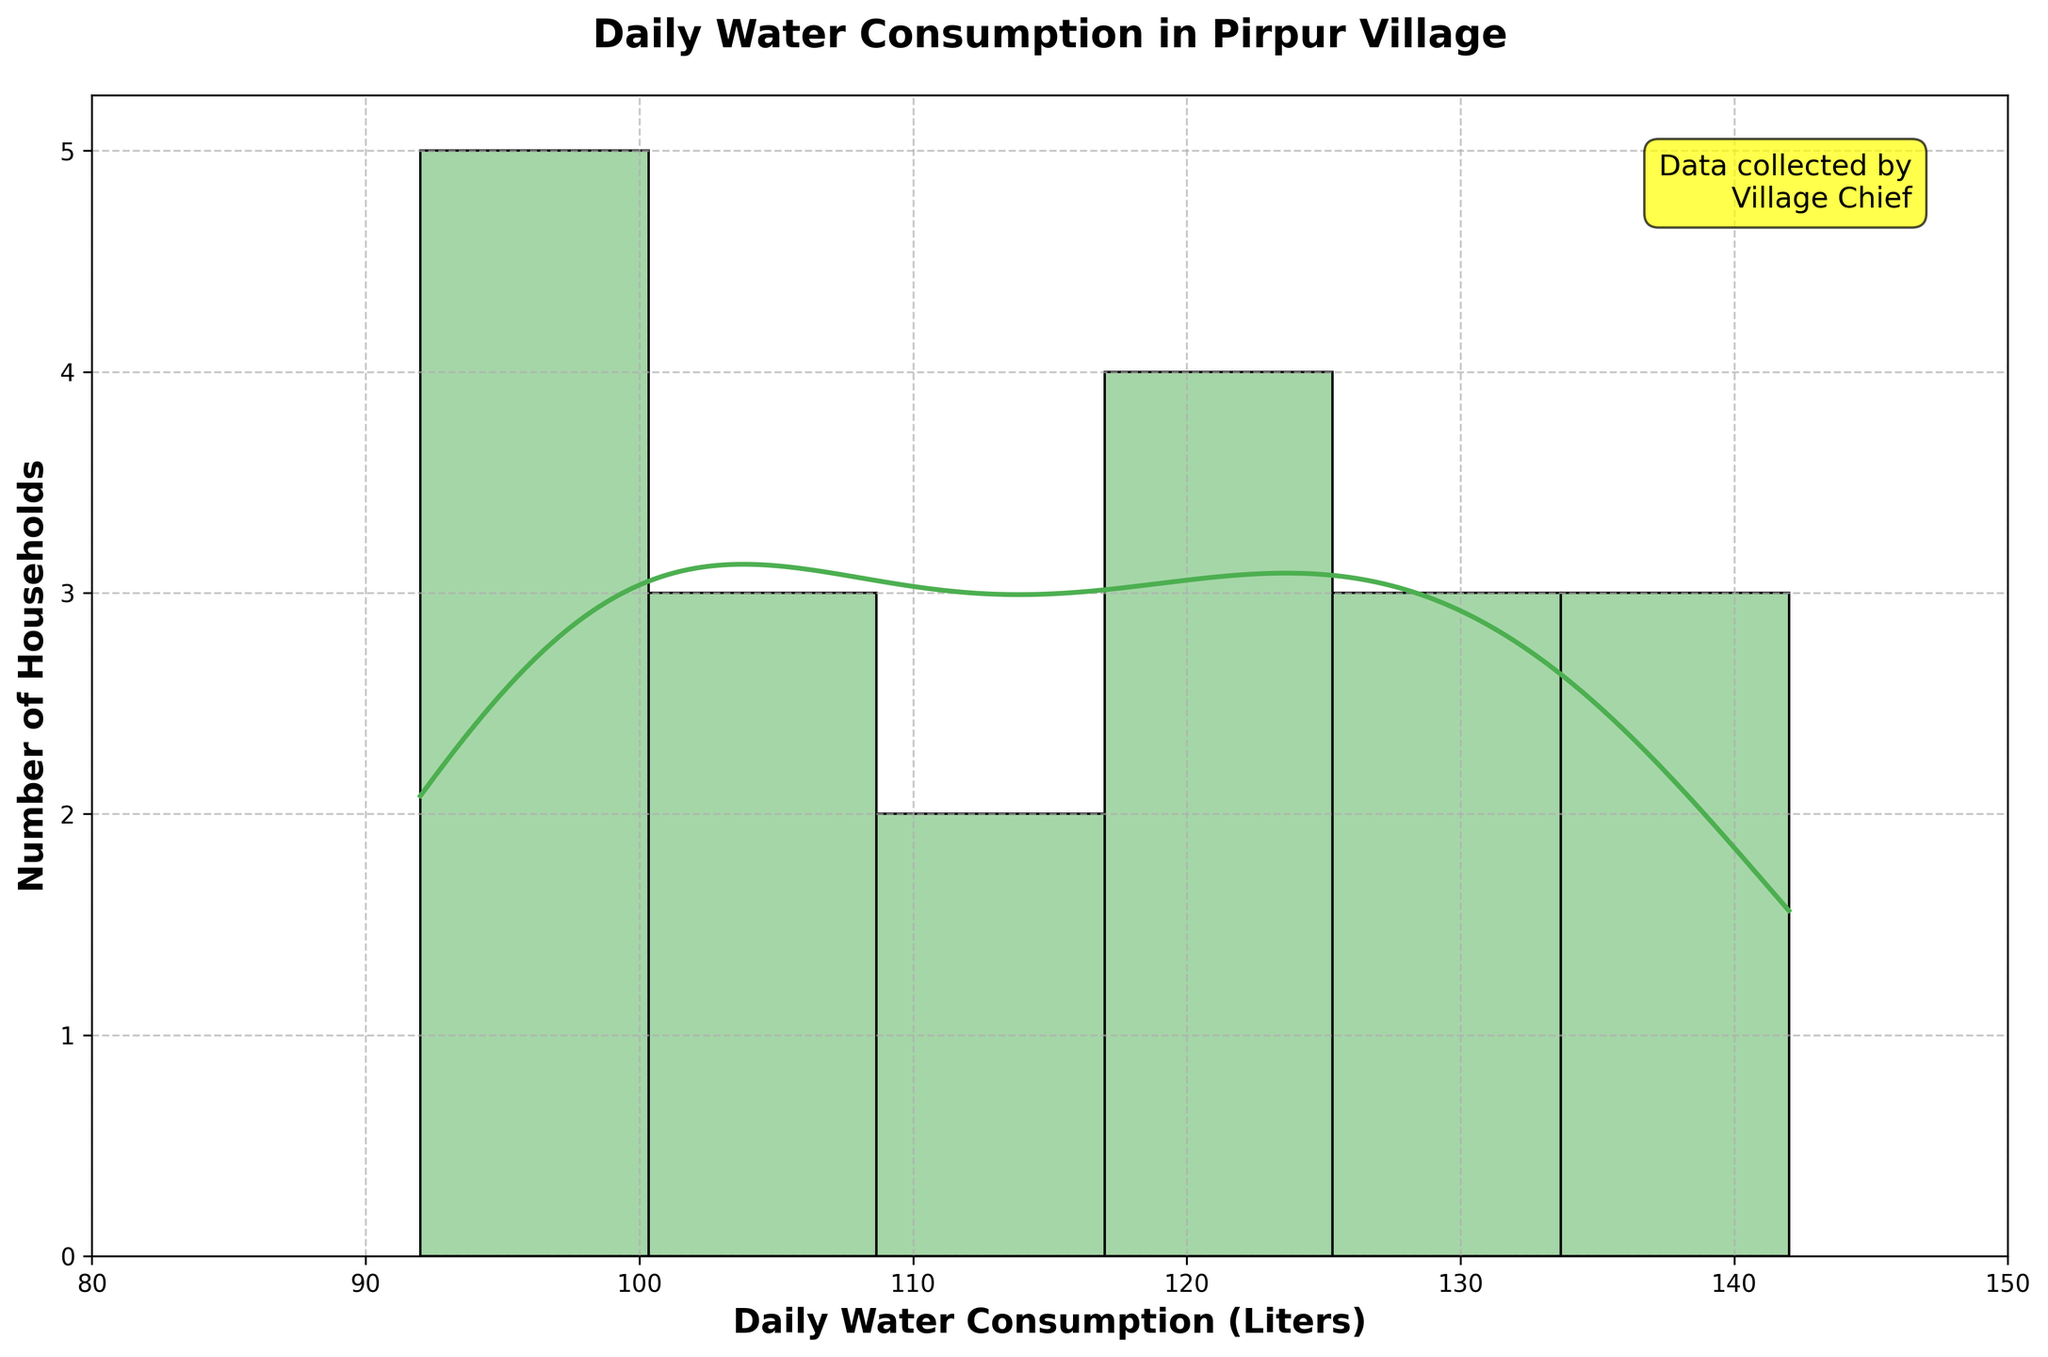What is the title of this figure? The title of the figure is located at the top-center of the chart and is displayed in bold font.
Answer: Daily Water Consumption in Pirpur Village What is the range of daily water consumption shown on the x-axis? The x-axis range can be deduced by looking at the start and end labels on the x-axis.
Answer: 80 to 150 liters How many households fall within the 90-110 liters range of daily water consumption? To find this, observe the height of the bars in the histogram within the 90-110 liters region and sum the number of households indicated by those bars.
Answer: 7 households Which color represents the density curve? The density curve (KDE) is drawn above the histogram and is represented in a different color.
Answer: Orange What is the most common daily water consumption range for the households? The most common daily water consumption range can be identified by locating the tallest bar in the histogram (mode) and noting the range it falls within.
Answer: 120-130 liters Compare the density at 100 liters and 130 liters. Which one is higher? Check the KDE curve at 100 liters and 130 liters. Compare their heights to determine which is higher.
Answer: 130 liters What is the purpose of the text annotation on the plot? The text annotation provides additional context or credits about the data collection or the plot itself.
Answer: To indicate that the data was collected by the Village Chief Estimate the median daily water consumption from the plot. To estimate the median, look for the value on the x-axis where approximately half of the area under the histogram and density curve lies to the left and half to the right.
Answer: Approximately 120 liters What is the shape of the distribution of daily water consumption? The shape of the distribution can be described by looking at the overall pattern of the histogram and density curve, whether it is skewed, symmetric, etc.
Answer: Slightly right-skewed How does the grid affect the readability of the chart? The grid can make it easier to approximate the values and compare different points on the chart by providing reference lines.
Answer: It improves readability by providing reference lines 